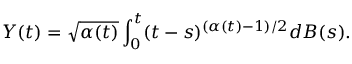<formula> <loc_0><loc_0><loc_500><loc_500>Y ( t ) = \sqrt { \alpha ( t ) } \int _ { 0 } ^ { t } ( t - s ) ^ { ( \alpha ( t ) - 1 ) / 2 } d B ( s ) .</formula> 